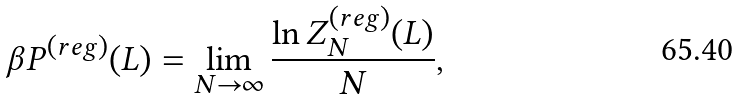Convert formula to latex. <formula><loc_0><loc_0><loc_500><loc_500>\beta P ^ { ( r e g ) } ( L ) = \lim _ { N \to \infty } \frac { \ln Z _ { N } ^ { ( r e g ) } ( L ) } { N } ,</formula> 